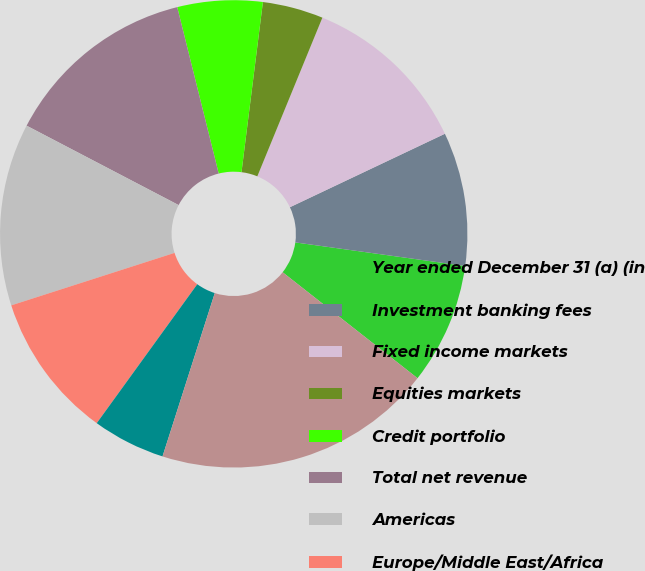<chart> <loc_0><loc_0><loc_500><loc_500><pie_chart><fcel>Year ended December 31 (a) (in<fcel>Investment banking fees<fcel>Fixed income markets<fcel>Equities markets<fcel>Credit portfolio<fcel>Total net revenue<fcel>Americas<fcel>Europe/Middle East/Africa<fcel>Asia/Pacific<fcel>Total assets<nl><fcel>8.4%<fcel>9.24%<fcel>11.76%<fcel>4.2%<fcel>5.88%<fcel>13.45%<fcel>12.61%<fcel>10.08%<fcel>5.04%<fcel>19.33%<nl></chart> 